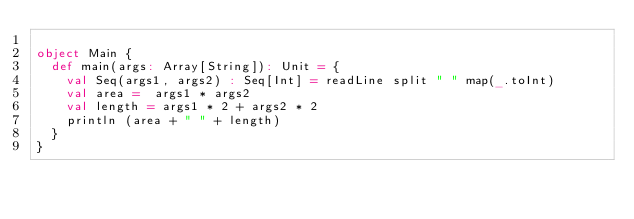Convert code to text. <code><loc_0><loc_0><loc_500><loc_500><_Scala_>
object Main {
  def main(args: Array[String]): Unit = {
    val Seq(args1, args2) : Seq[Int] = readLine split " " map(_.toInt)
    val area =  args1 * args2
    val length = args1 * 2 + args2 * 2 
    println (area + " " + length) 
  }
}</code> 